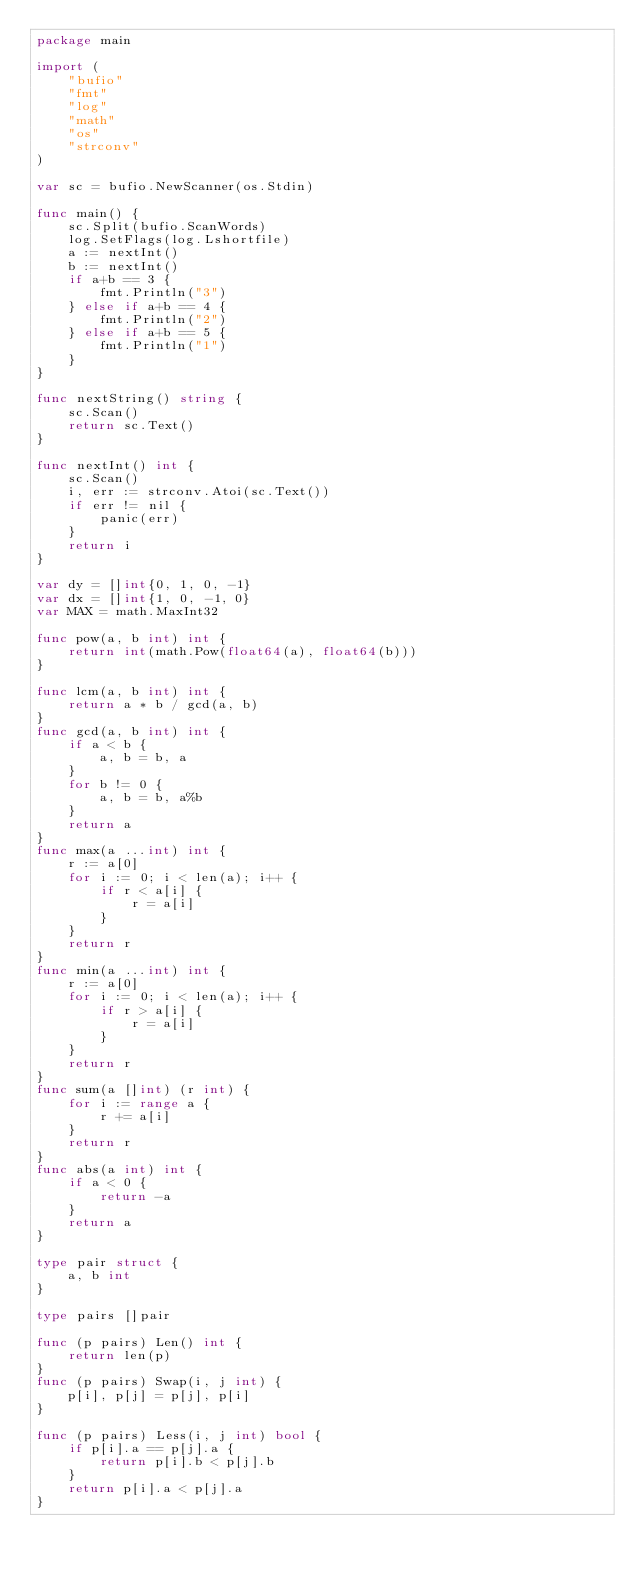<code> <loc_0><loc_0><loc_500><loc_500><_Go_>package main

import (
	"bufio"
	"fmt"
	"log"
	"math"
	"os"
	"strconv"
)

var sc = bufio.NewScanner(os.Stdin)

func main() {
	sc.Split(bufio.ScanWords)
	log.SetFlags(log.Lshortfile)
	a := nextInt()
	b := nextInt()
	if a+b == 3 {
		fmt.Println("3")
	} else if a+b == 4 {
		fmt.Println("2")
	} else if a+b == 5 {
		fmt.Println("1")
	}
}

func nextString() string {
	sc.Scan()
	return sc.Text()
}

func nextInt() int {
	sc.Scan()
	i, err := strconv.Atoi(sc.Text())
	if err != nil {
		panic(err)
	}
	return i
}

var dy = []int{0, 1, 0, -1}
var dx = []int{1, 0, -1, 0}
var MAX = math.MaxInt32

func pow(a, b int) int {
	return int(math.Pow(float64(a), float64(b)))
}

func lcm(a, b int) int {
	return a * b / gcd(a, b)
}
func gcd(a, b int) int {
	if a < b {
		a, b = b, a
	}
	for b != 0 {
		a, b = b, a%b
	}
	return a
}
func max(a ...int) int {
	r := a[0]
	for i := 0; i < len(a); i++ {
		if r < a[i] {
			r = a[i]
		}
	}
	return r
}
func min(a ...int) int {
	r := a[0]
	for i := 0; i < len(a); i++ {
		if r > a[i] {
			r = a[i]
		}
	}
	return r
}
func sum(a []int) (r int) {
	for i := range a {
		r += a[i]
	}
	return r
}
func abs(a int) int {
	if a < 0 {
		return -a
	}
	return a
}

type pair struct {
	a, b int
}

type pairs []pair

func (p pairs) Len() int {
	return len(p)
}
func (p pairs) Swap(i, j int) {
	p[i], p[j] = p[j], p[i]
}

func (p pairs) Less(i, j int) bool {
	if p[i].a == p[j].a {
		return p[i].b < p[j].b
	}
	return p[i].a < p[j].a
}
</code> 